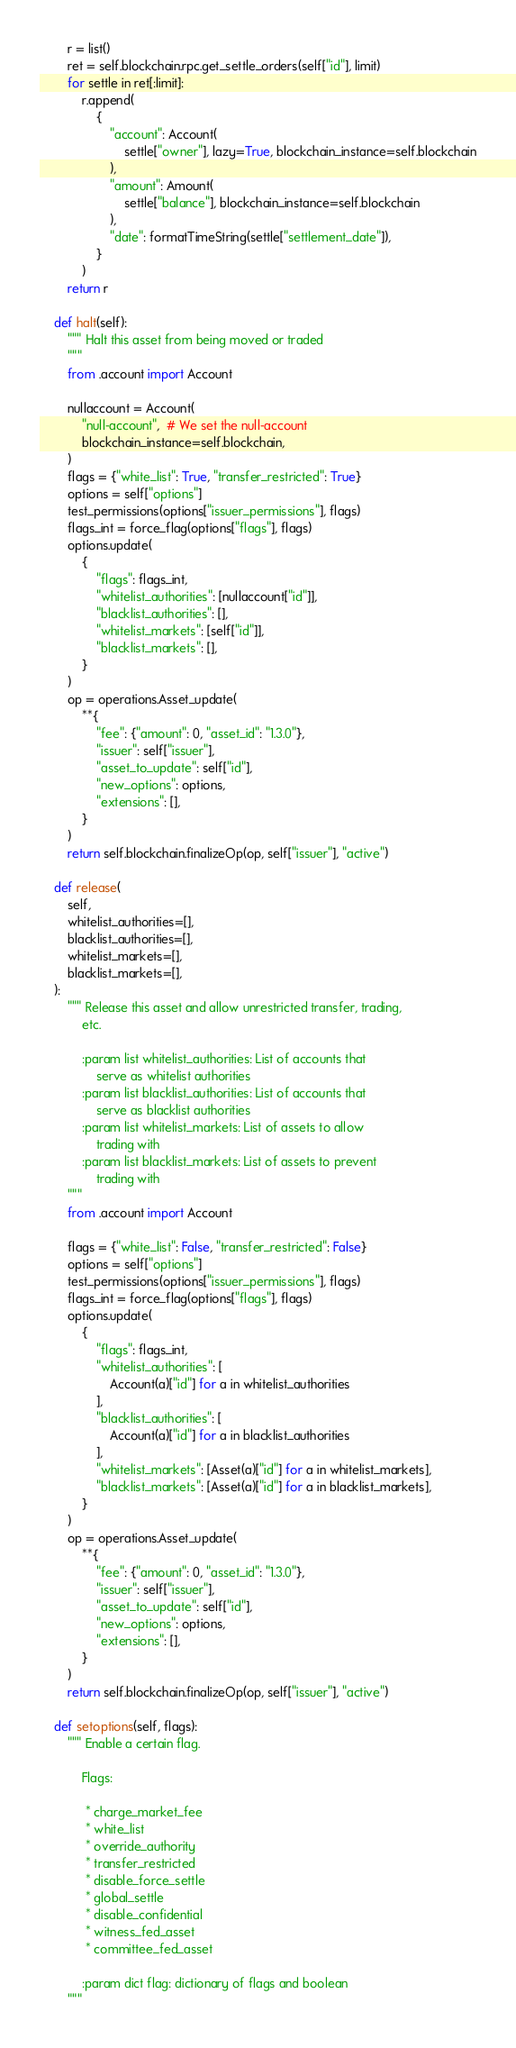Convert code to text. <code><loc_0><loc_0><loc_500><loc_500><_Python_>        r = list()
        ret = self.blockchain.rpc.get_settle_orders(self["id"], limit)
        for settle in ret[:limit]:
            r.append(
                {
                    "account": Account(
                        settle["owner"], lazy=True, blockchain_instance=self.blockchain
                    ),
                    "amount": Amount(
                        settle["balance"], blockchain_instance=self.blockchain
                    ),
                    "date": formatTimeString(settle["settlement_date"]),
                }
            )
        return r

    def halt(self):
        """ Halt this asset from being moved or traded
        """
        from .account import Account

        nullaccount = Account(
            "null-account",  # We set the null-account
            blockchain_instance=self.blockchain,
        )
        flags = {"white_list": True, "transfer_restricted": True}
        options = self["options"]
        test_permissions(options["issuer_permissions"], flags)
        flags_int = force_flag(options["flags"], flags)
        options.update(
            {
                "flags": flags_int,
                "whitelist_authorities": [nullaccount["id"]],
                "blacklist_authorities": [],
                "whitelist_markets": [self["id"]],
                "blacklist_markets": [],
            }
        )
        op = operations.Asset_update(
            **{
                "fee": {"amount": 0, "asset_id": "1.3.0"},
                "issuer": self["issuer"],
                "asset_to_update": self["id"],
                "new_options": options,
                "extensions": [],
            }
        )
        return self.blockchain.finalizeOp(op, self["issuer"], "active")

    def release(
        self,
        whitelist_authorities=[],
        blacklist_authorities=[],
        whitelist_markets=[],
        blacklist_markets=[],
    ):
        """ Release this asset and allow unrestricted transfer, trading,
            etc.

            :param list whitelist_authorities: List of accounts that
                serve as whitelist authorities
            :param list blacklist_authorities: List of accounts that
                serve as blacklist authorities
            :param list whitelist_markets: List of assets to allow
                trading with
            :param list blacklist_markets: List of assets to prevent
                trading with
        """
        from .account import Account

        flags = {"white_list": False, "transfer_restricted": False}
        options = self["options"]
        test_permissions(options["issuer_permissions"], flags)
        flags_int = force_flag(options["flags"], flags)
        options.update(
            {
                "flags": flags_int,
                "whitelist_authorities": [
                    Account(a)["id"] for a in whitelist_authorities
                ],
                "blacklist_authorities": [
                    Account(a)["id"] for a in blacklist_authorities
                ],
                "whitelist_markets": [Asset(a)["id"] for a in whitelist_markets],
                "blacklist_markets": [Asset(a)["id"] for a in blacklist_markets],
            }
        )
        op = operations.Asset_update(
            **{
                "fee": {"amount": 0, "asset_id": "1.3.0"},
                "issuer": self["issuer"],
                "asset_to_update": self["id"],
                "new_options": options,
                "extensions": [],
            }
        )
        return self.blockchain.finalizeOp(op, self["issuer"], "active")

    def setoptions(self, flags):
        """ Enable a certain flag.

            Flags:

             * charge_market_fee
             * white_list
             * override_authority
             * transfer_restricted
             * disable_force_settle
             * global_settle
             * disable_confidential
             * witness_fed_asset
             * committee_fed_asset

            :param dict flag: dictionary of flags and boolean
        """</code> 